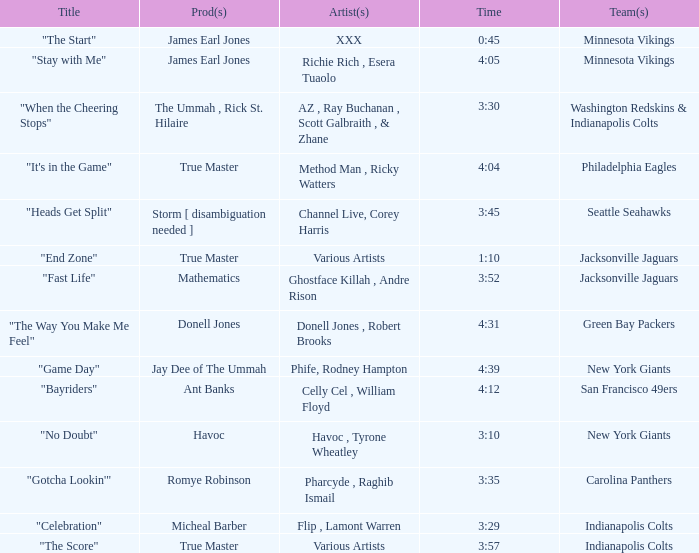Who is the artist of the Seattle Seahawks track? Channel Live, Corey Harris. 